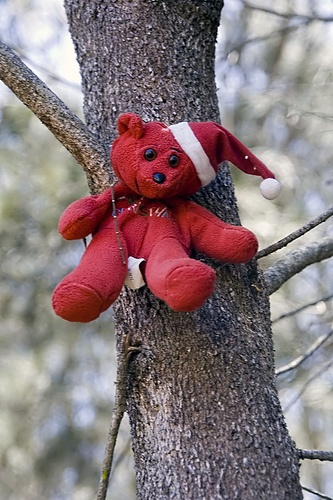Describe the objects in this image and their specific colors. I can see a teddy bear in darkgray, brown, and maroon tones in this image. 